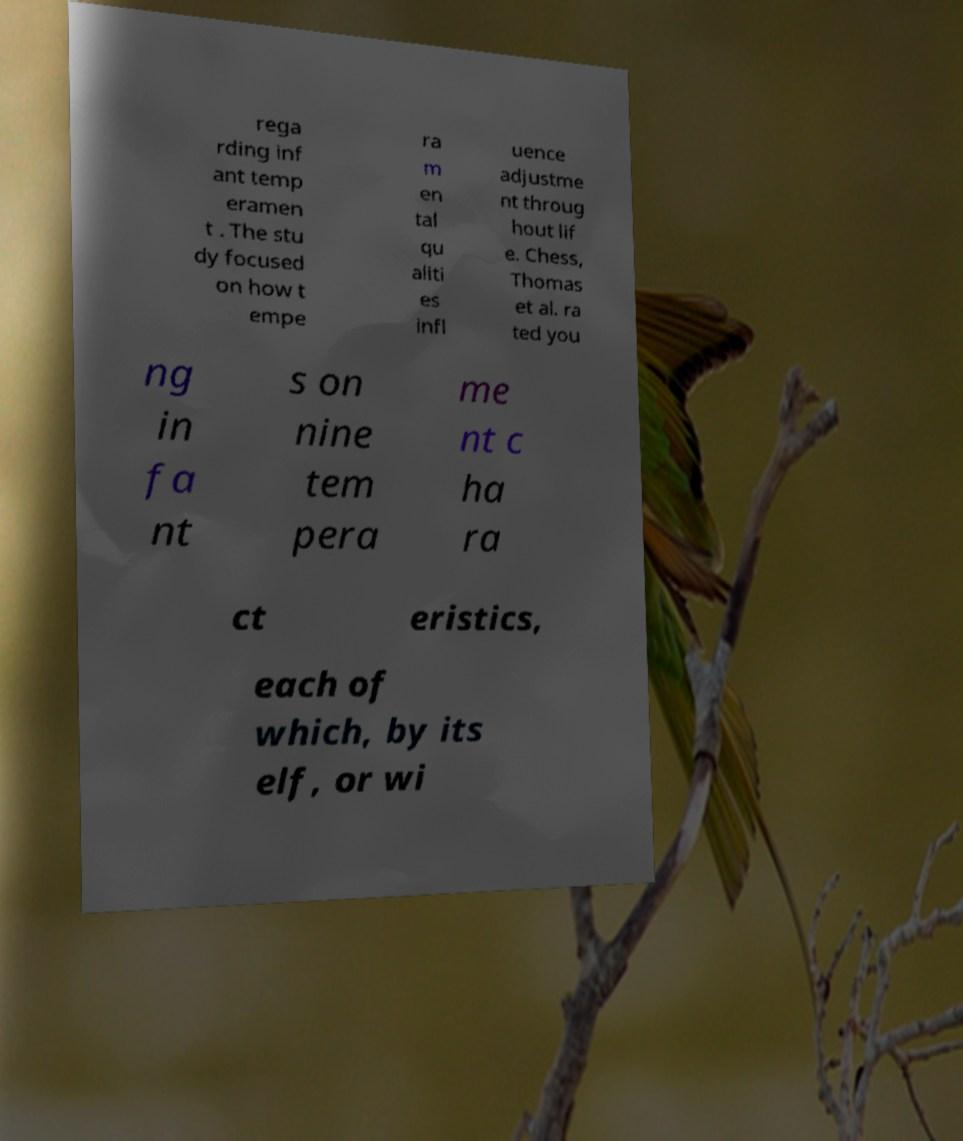Please identify and transcribe the text found in this image. rega rding inf ant temp eramen t . The stu dy focused on how t empe ra m en tal qu aliti es infl uence adjustme nt throug hout lif e. Chess, Thomas et al. ra ted you ng in fa nt s on nine tem pera me nt c ha ra ct eristics, each of which, by its elf, or wi 